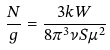Convert formula to latex. <formula><loc_0><loc_0><loc_500><loc_500>\frac { N } { g } = \frac { 3 k W } { 8 \pi ^ { 3 } \nu S \mu ^ { 2 } }</formula> 